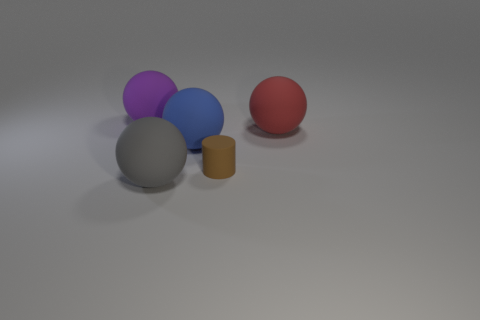What material is the large gray thing that is the same shape as the large purple thing?
Offer a very short reply. Rubber. Are the large sphere that is to the right of the large blue object and the brown cylinder made of the same material?
Your response must be concise. Yes. Is the number of gray rubber objects that are right of the large red matte ball greater than the number of small brown objects behind the tiny thing?
Provide a short and direct response. No. What is the size of the gray matte thing?
Your answer should be very brief. Large. The big purple object that is the same material as the tiny brown thing is what shape?
Make the answer very short. Sphere. There is a big thing that is in front of the tiny brown cylinder; is it the same shape as the red matte thing?
Your answer should be very brief. Yes. What number of objects are either yellow balls or balls?
Keep it short and to the point. 4. There is a large sphere that is left of the big red rubber sphere and to the right of the big gray ball; what material is it?
Your answer should be compact. Rubber. Is the purple object the same size as the brown cylinder?
Offer a terse response. No. What is the size of the rubber sphere in front of the big blue matte sphere that is behind the big gray sphere?
Offer a terse response. Large. 